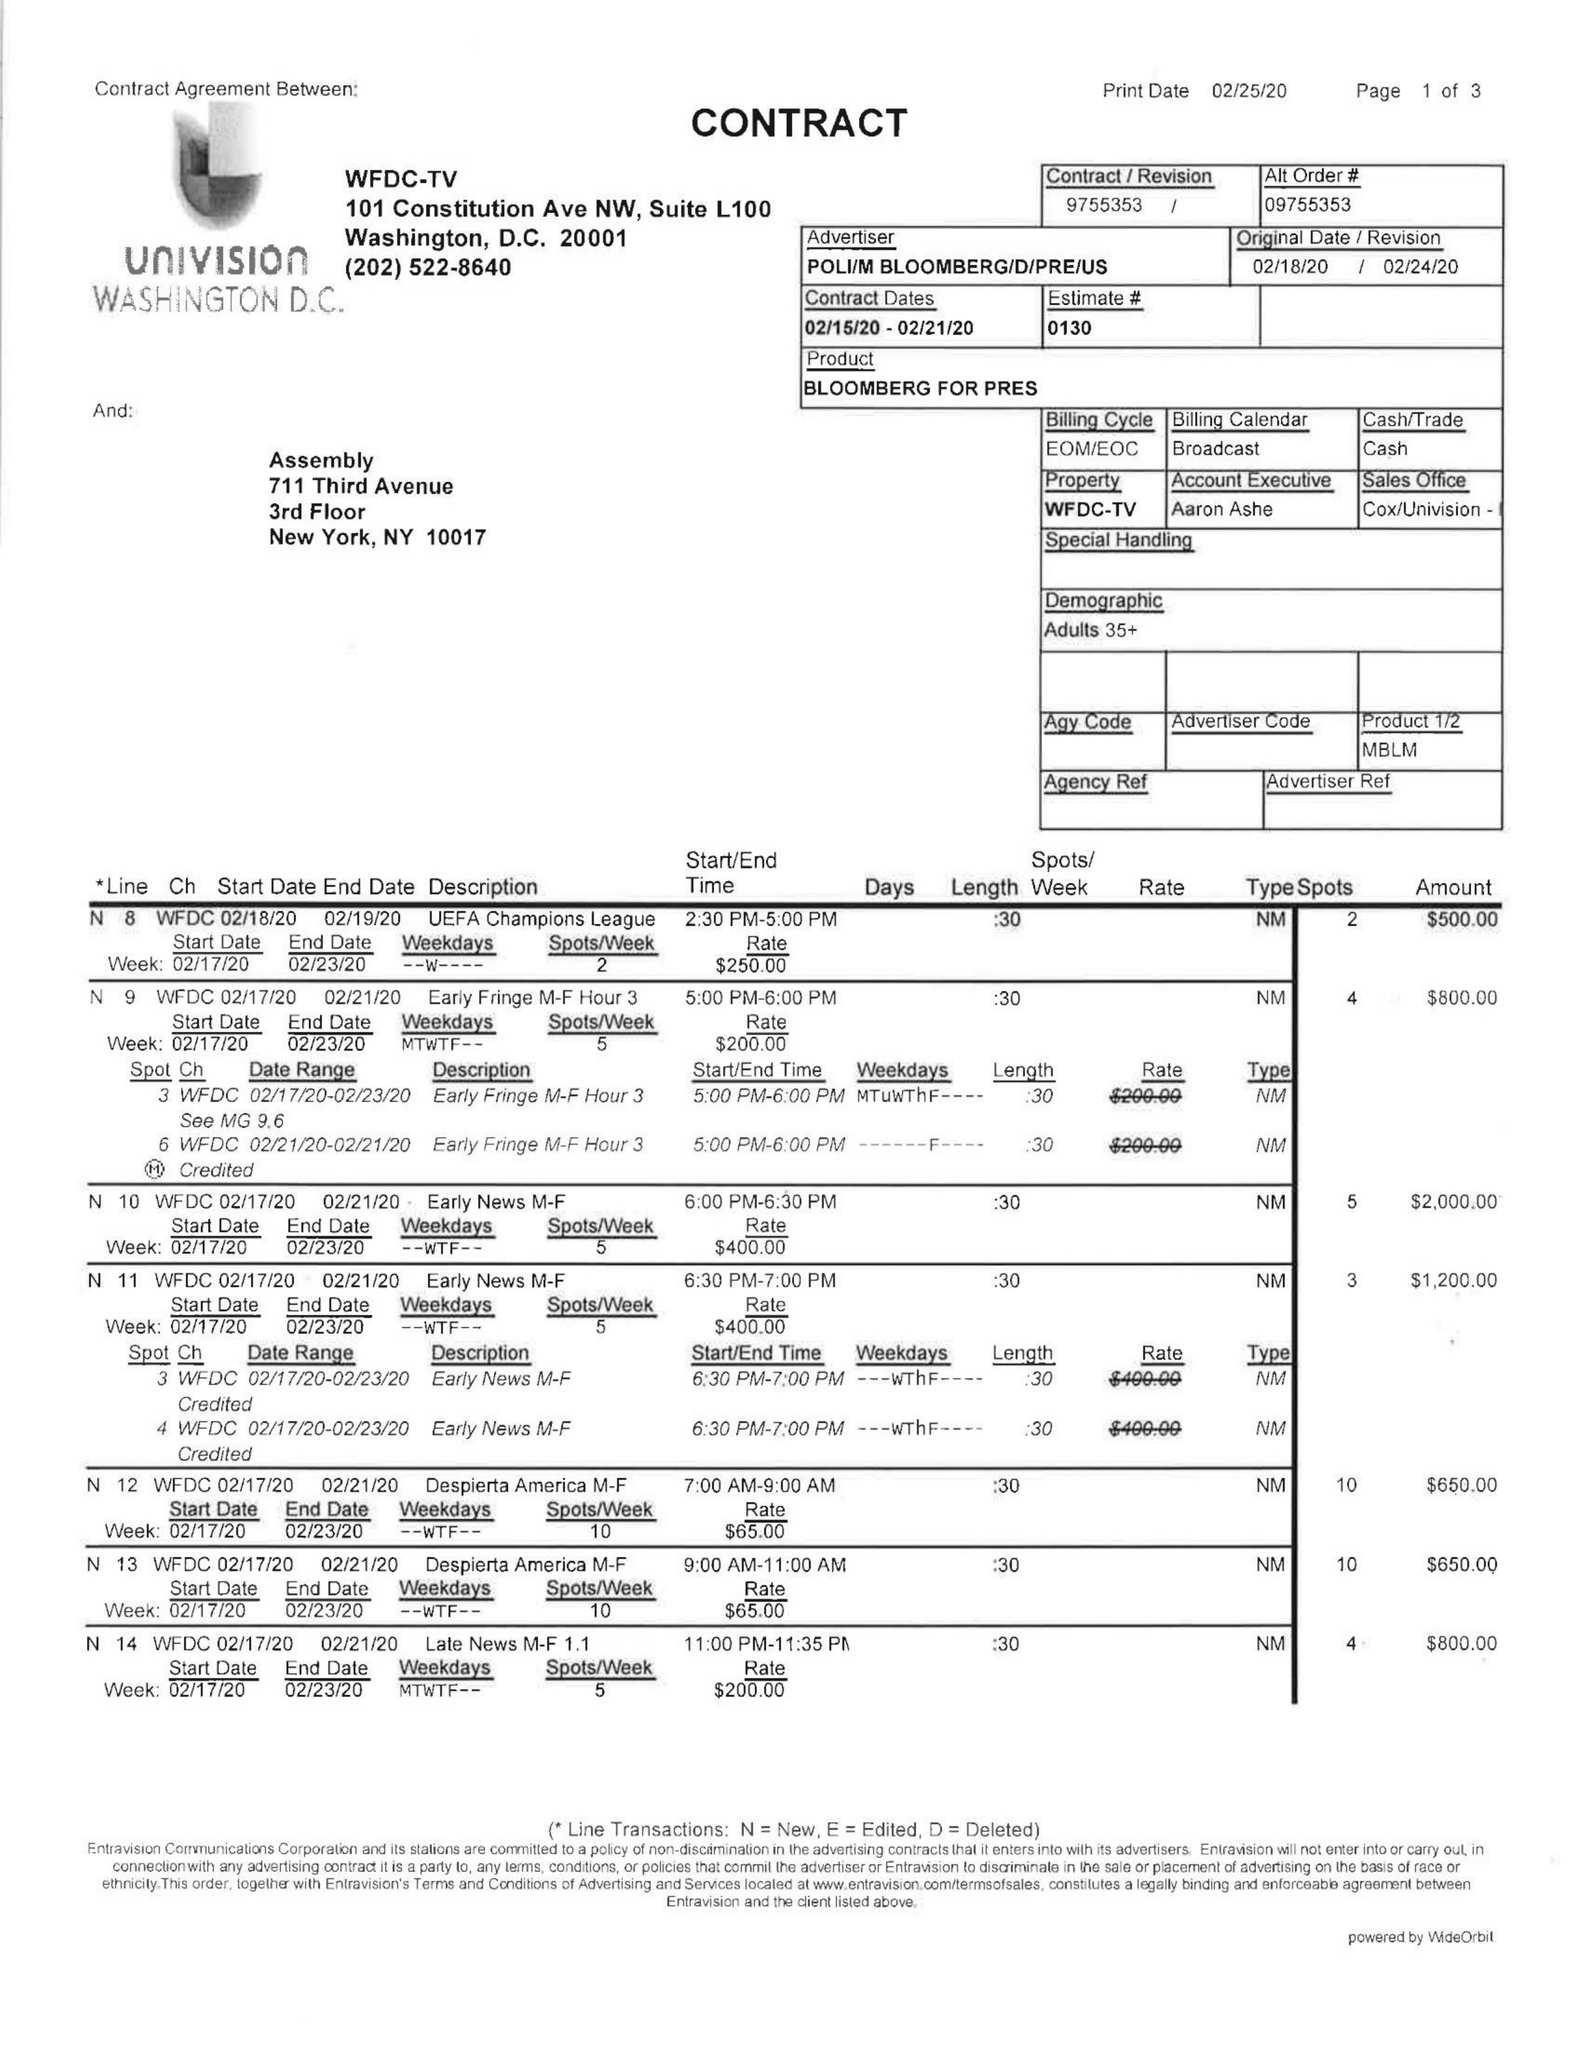What is the value for the flight_to?
Answer the question using a single word or phrase. 02/21/20 